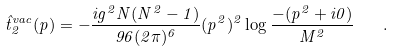<formula> <loc_0><loc_0><loc_500><loc_500>\hat { t } ^ { v a c } _ { 2 } ( p ) = - \frac { i g ^ { 2 } N ( N ^ { 2 } - 1 ) } { 9 6 ( 2 \pi ) ^ { 6 } } ( p ^ { 2 } ) ^ { 2 } \log \frac { - ( p ^ { 2 } + i 0 ) } { M ^ { 2 } } \quad .</formula> 